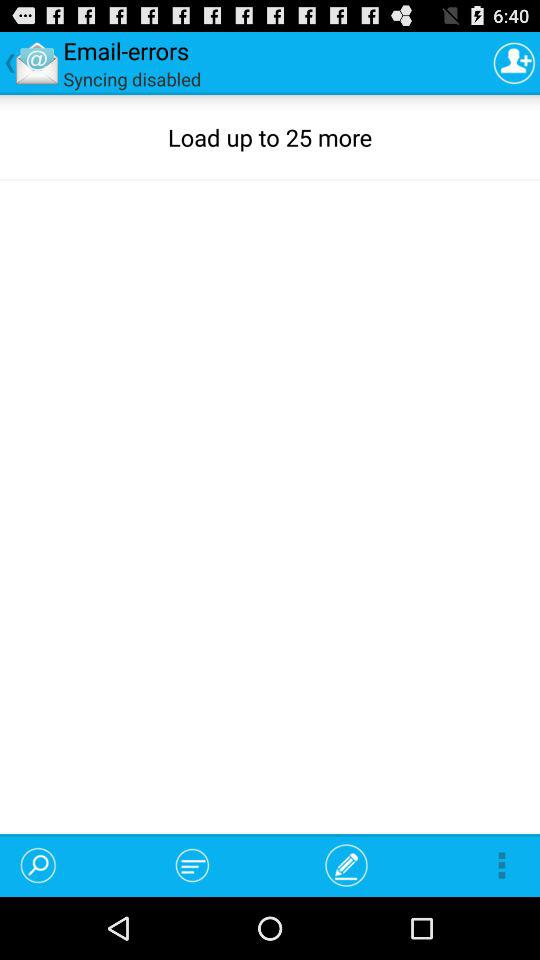How many files can be loaded? You can load up to 25 files. 